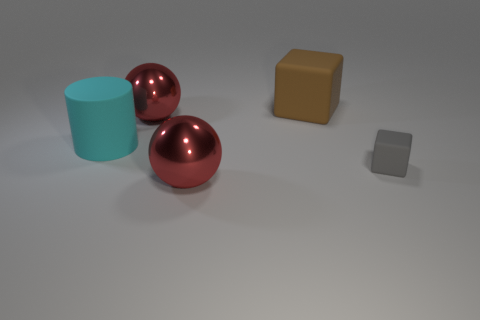Subtract all cylinders. How many objects are left? 4 Subtract 1 blocks. How many blocks are left? 1 Subtract all cyan things. Subtract all big cyan metallic balls. How many objects are left? 4 Add 1 cyan objects. How many cyan objects are left? 2 Add 4 large shiny spheres. How many large shiny spheres exist? 6 Add 4 gray matte cubes. How many objects exist? 9 Subtract 0 purple spheres. How many objects are left? 5 Subtract all brown cubes. Subtract all brown cylinders. How many cubes are left? 1 Subtract all green balls. How many gray cubes are left? 1 